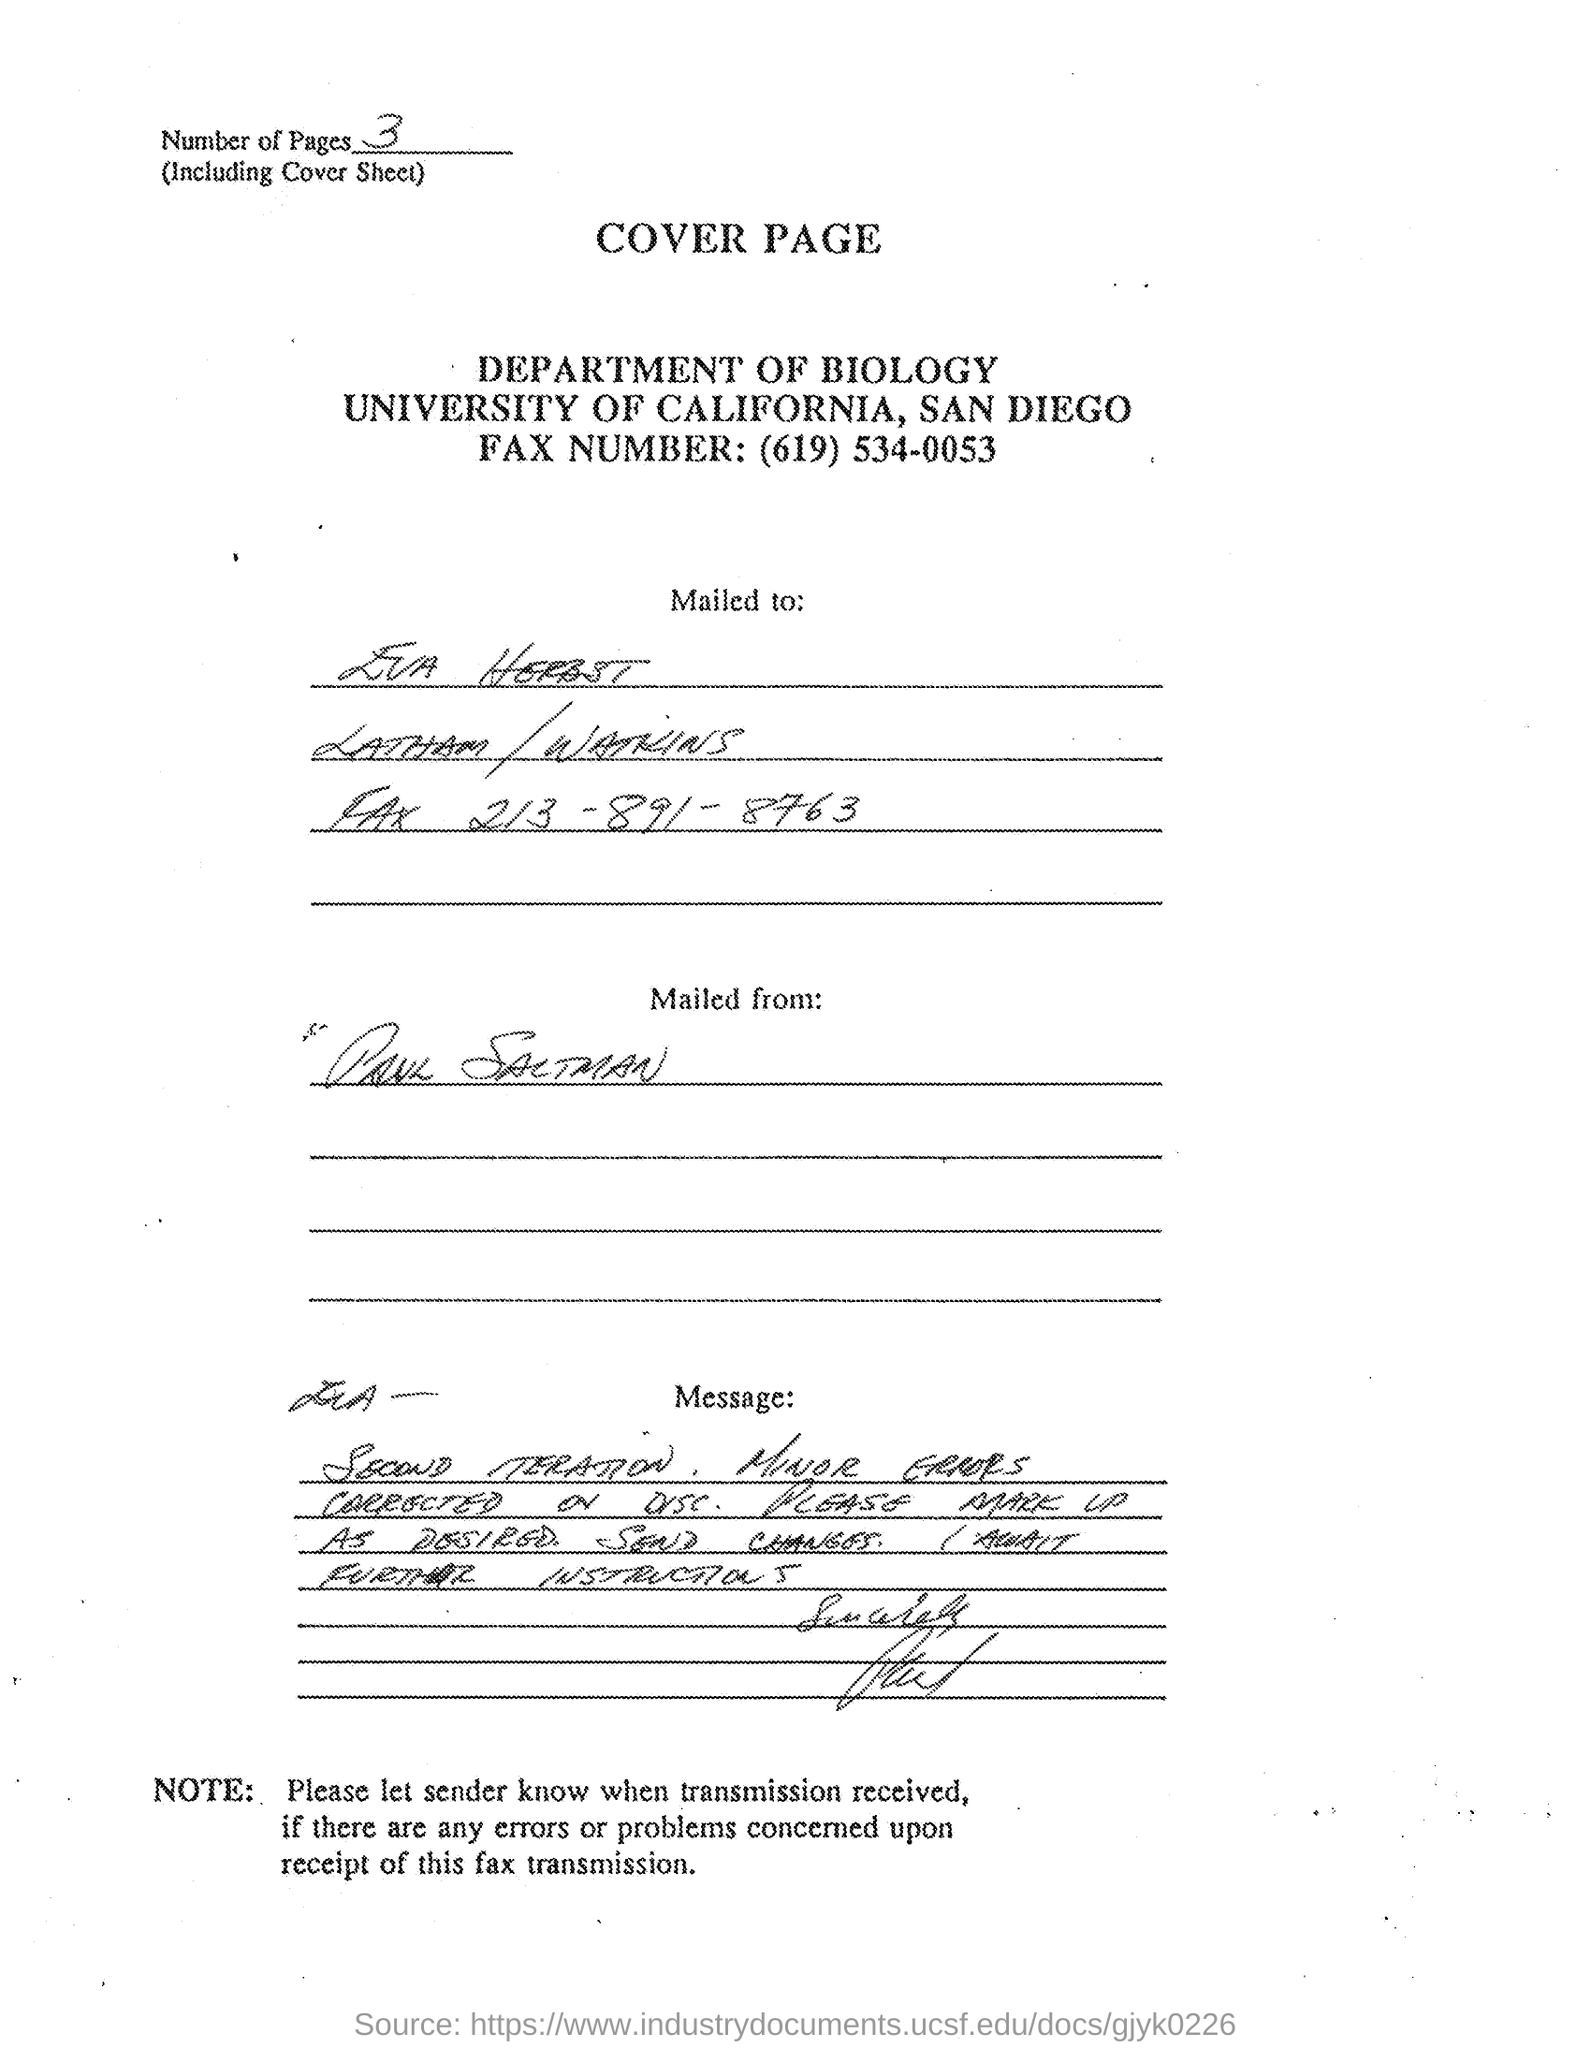Highlight a few significant elements in this photo. The recipient of the letter is Eva Herbst. The sender's name is Paul Saltman. 